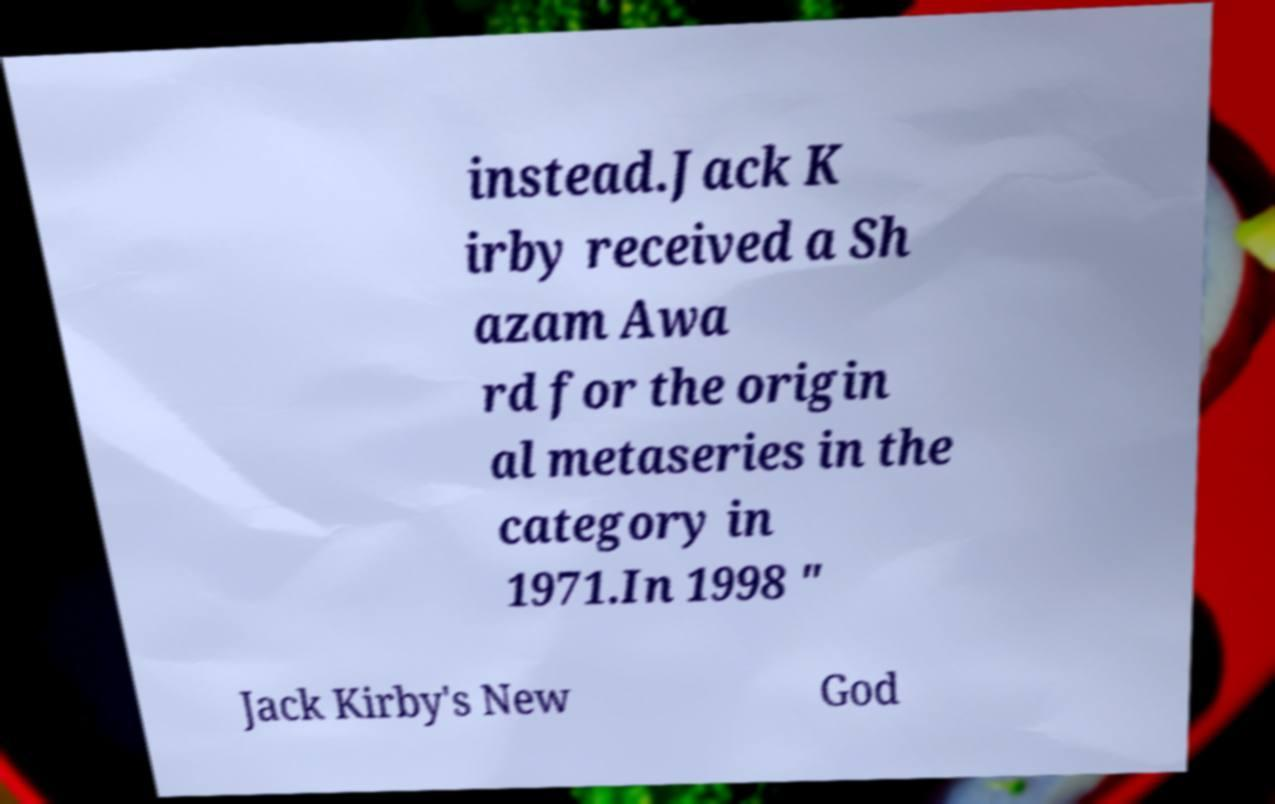Could you extract and type out the text from this image? instead.Jack K irby received a Sh azam Awa rd for the origin al metaseries in the category in 1971.In 1998 " Jack Kirby's New God 